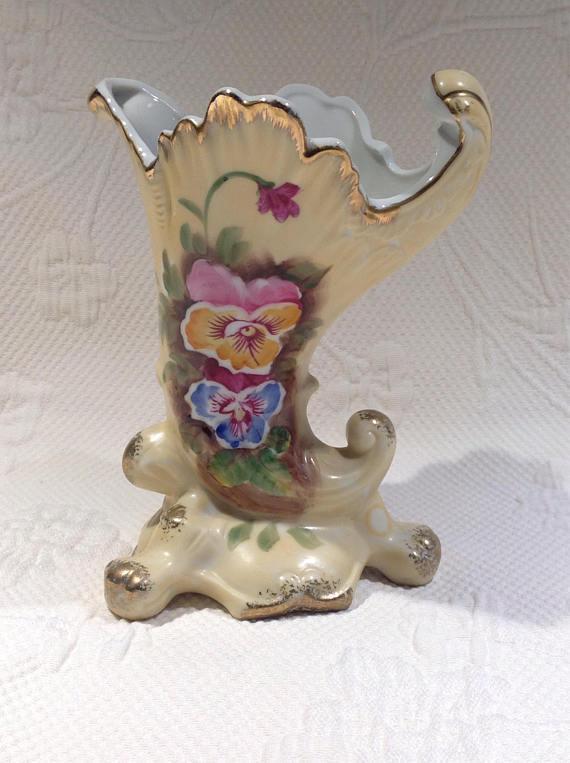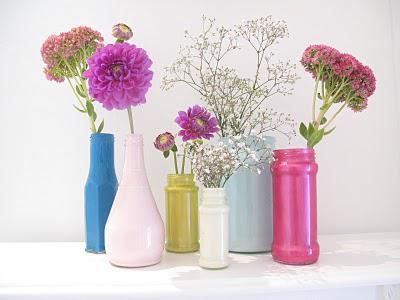The first image is the image on the left, the second image is the image on the right. Analyze the images presented: Is the assertion "None of the vases have flowers inserted into them." valid? Answer yes or no. No. The first image is the image on the left, the second image is the image on the right. Analyze the images presented: Is the assertion "None of the vases contain flowers." valid? Answer yes or no. No. 